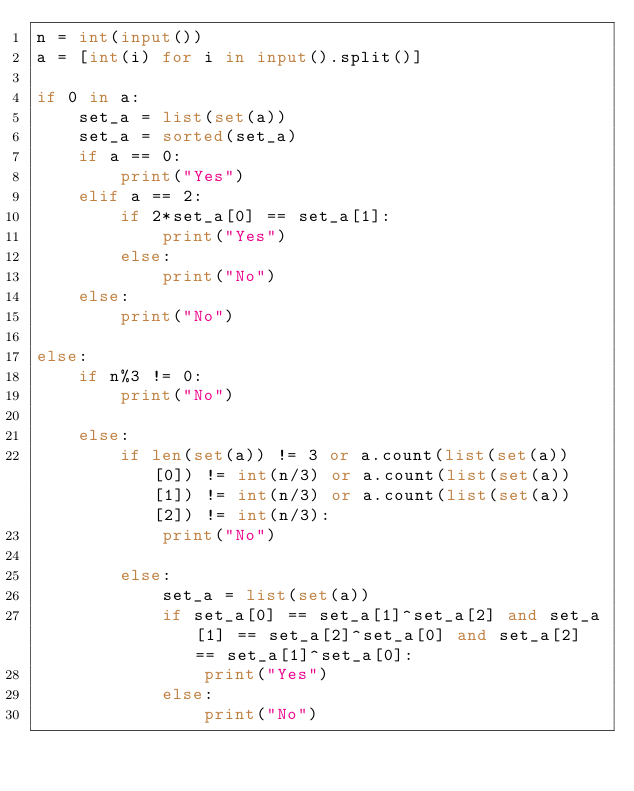<code> <loc_0><loc_0><loc_500><loc_500><_Python_>n = int(input())
a = [int(i) for i in input().split()]

if 0 in a:
    set_a = list(set(a))
    set_a = sorted(set_a)
    if a == 0:
        print("Yes")
    elif a == 2:
        if 2*set_a[0] == set_a[1]:
            print("Yes")
        else:
            print("No")
    else:
        print("No")

else:
    if n%3 != 0:
        print("No")

    else:
        if len(set(a)) != 3 or a.count(list(set(a))[0]) != int(n/3) or a.count(list(set(a))[1]) != int(n/3) or a.count(list(set(a))[2]) != int(n/3):
            print("No")

        else:
            set_a = list(set(a))
            if set_a[0] == set_a[1]^set_a[2] and set_a[1] == set_a[2]^set_a[0] and set_a[2] == set_a[1]^set_a[0]:
                print("Yes")
            else:
                print("No")
</code> 